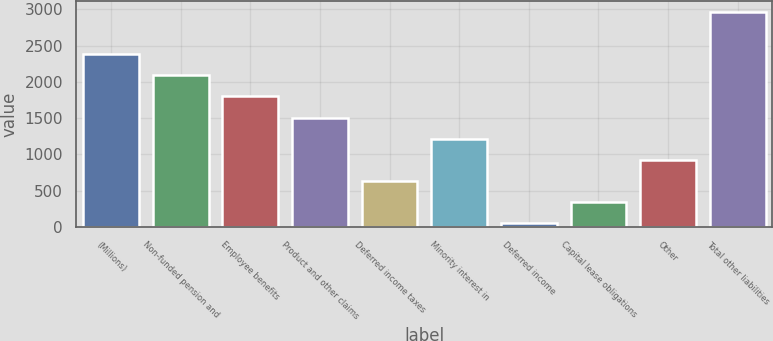Convert chart to OTSL. <chart><loc_0><loc_0><loc_500><loc_500><bar_chart><fcel>(Millions)<fcel>Non-funded pension and<fcel>Employee benefits<fcel>Product and other claims<fcel>Deferred income taxes<fcel>Minority interest in<fcel>Deferred income<fcel>Capital lease obligations<fcel>Other<fcel>Total other liabilities<nl><fcel>2382<fcel>2090.5<fcel>1799<fcel>1507.5<fcel>633<fcel>1216<fcel>50<fcel>341.5<fcel>924.5<fcel>2965<nl></chart> 